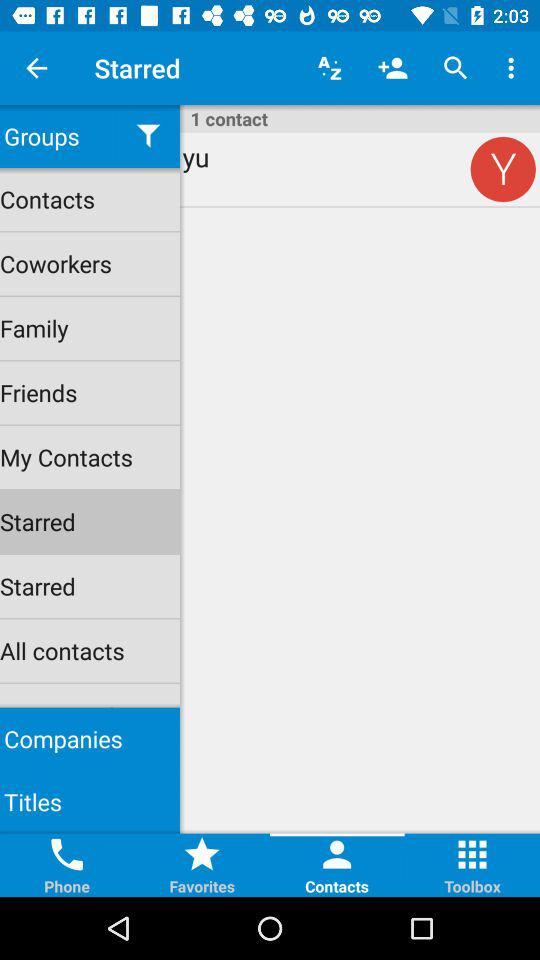Which option has been chosen under "Groups"? The option that has been chosen under "Groups" is "Starred". 